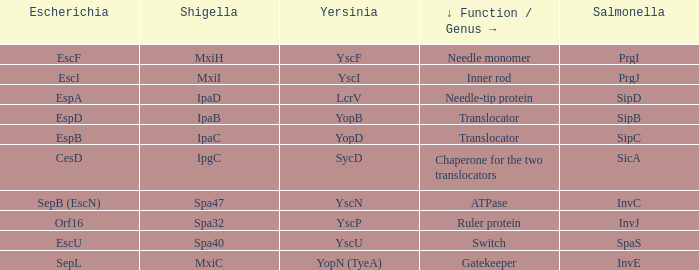Tell me the shigella and yscn Spa47. 